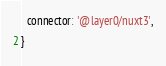Convert code to text. <code><loc_0><loc_0><loc_500><loc_500><_JavaScript_>  connector: '@layer0/nuxt3',
}
</code> 